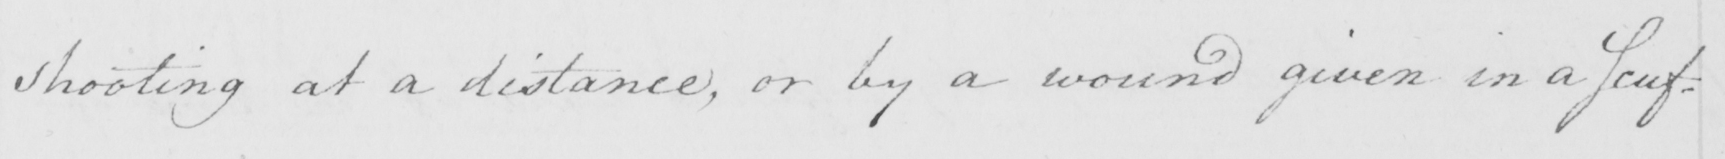Please provide the text content of this handwritten line. shooting at a distance , or by a wound given in a Scuf= 